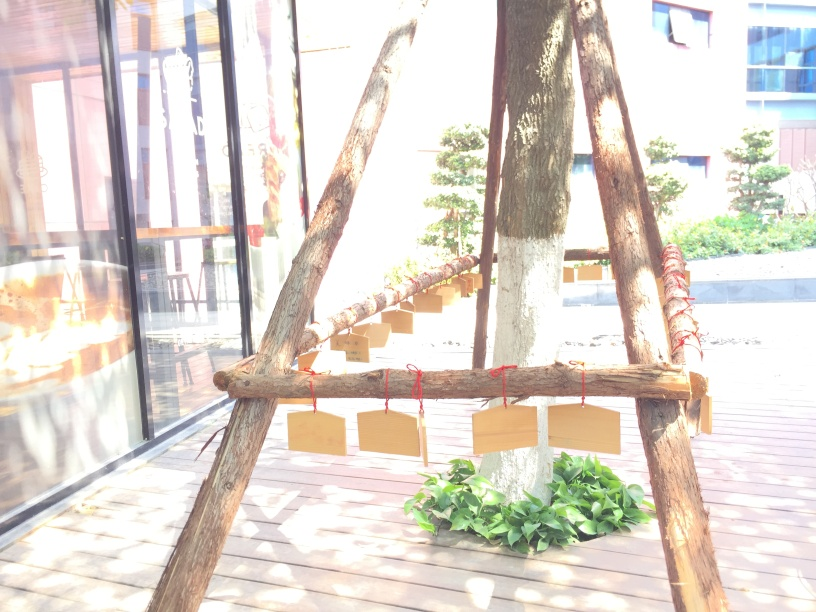What time of day does this photo seem to have been taken? Given the bright lighting and high contrast of shadows, it's likely the photo was taken close to midday when the sun is at its highest and light is most intense. 